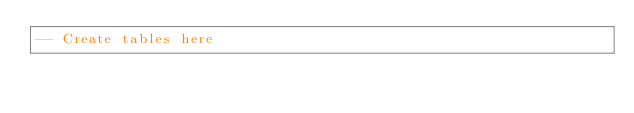<code> <loc_0><loc_0><loc_500><loc_500><_SQL_>-- Create tables here
</code> 